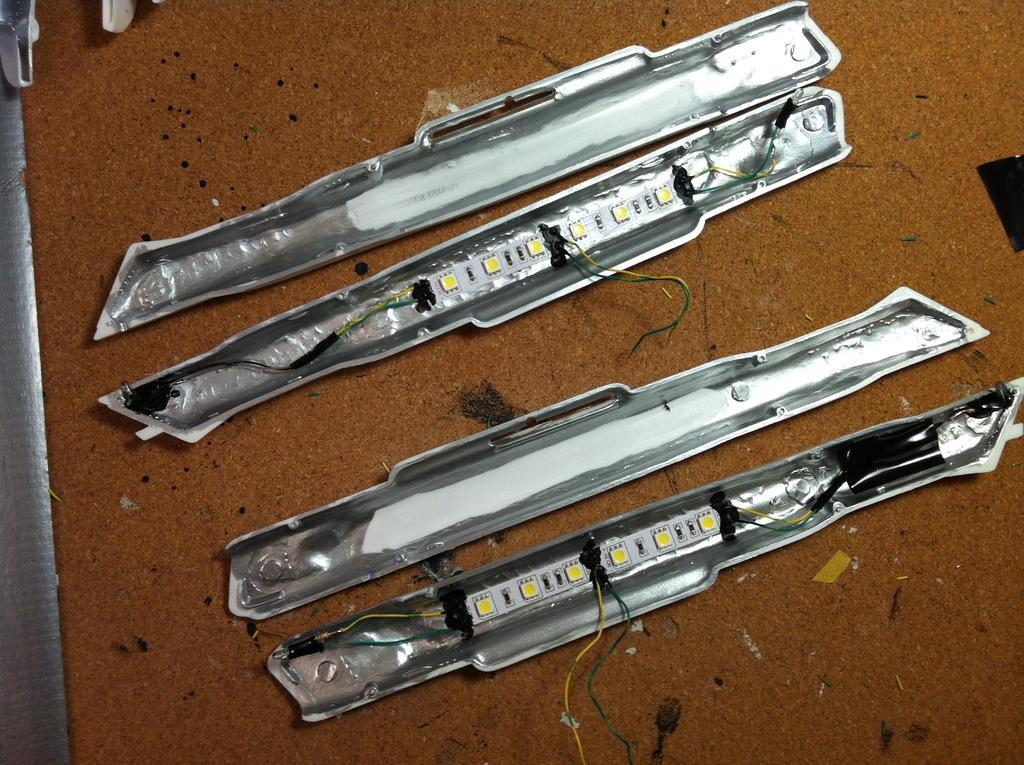Could you give a brief overview of what you see in this image? In this image I can see few objects on the brown color surface and I can also see few wires. 